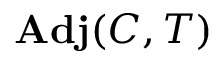<formula> <loc_0><loc_0><loc_500><loc_500>A d j ( C , T )</formula> 